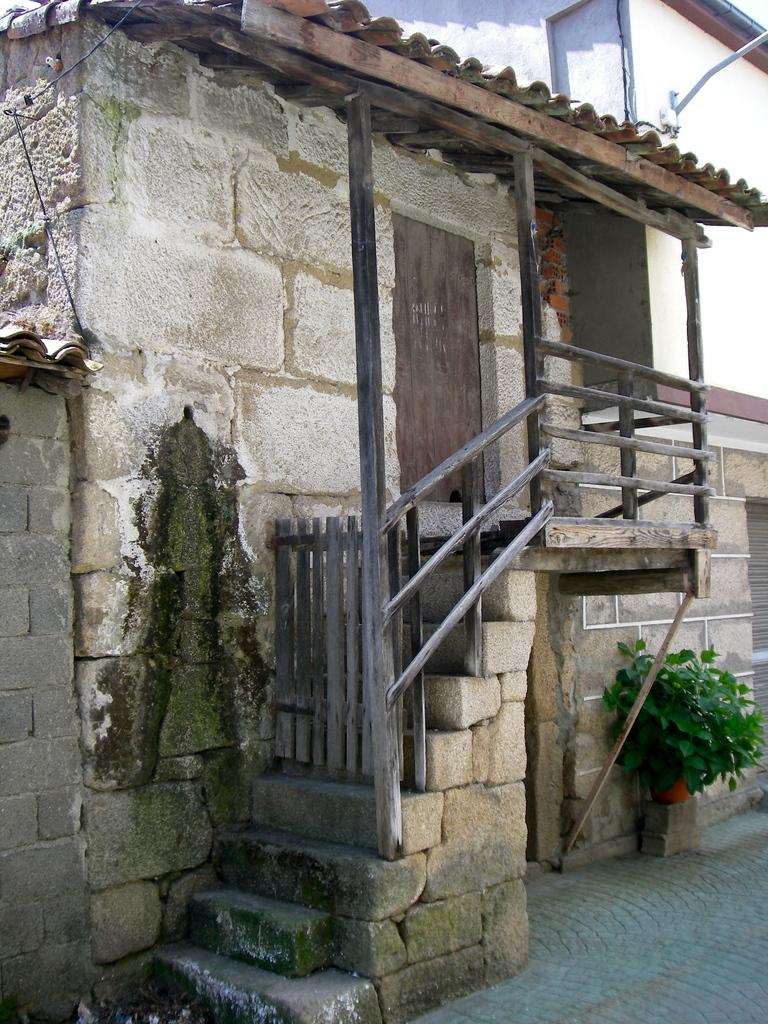What is the main structure in the middle of the image? There is a staircase in the middle of the image. What type of building might the staircase be a part of? The staircase appears to be part of a house. What can be seen on the right side of the image? There are plants on the right side of the image. What type of cream is being used to paint the box in the image? There is no box or cream present in the image. What type of voyage is depicted in the image? There is no voyage depicted in the image; it features a staircase and plants. 